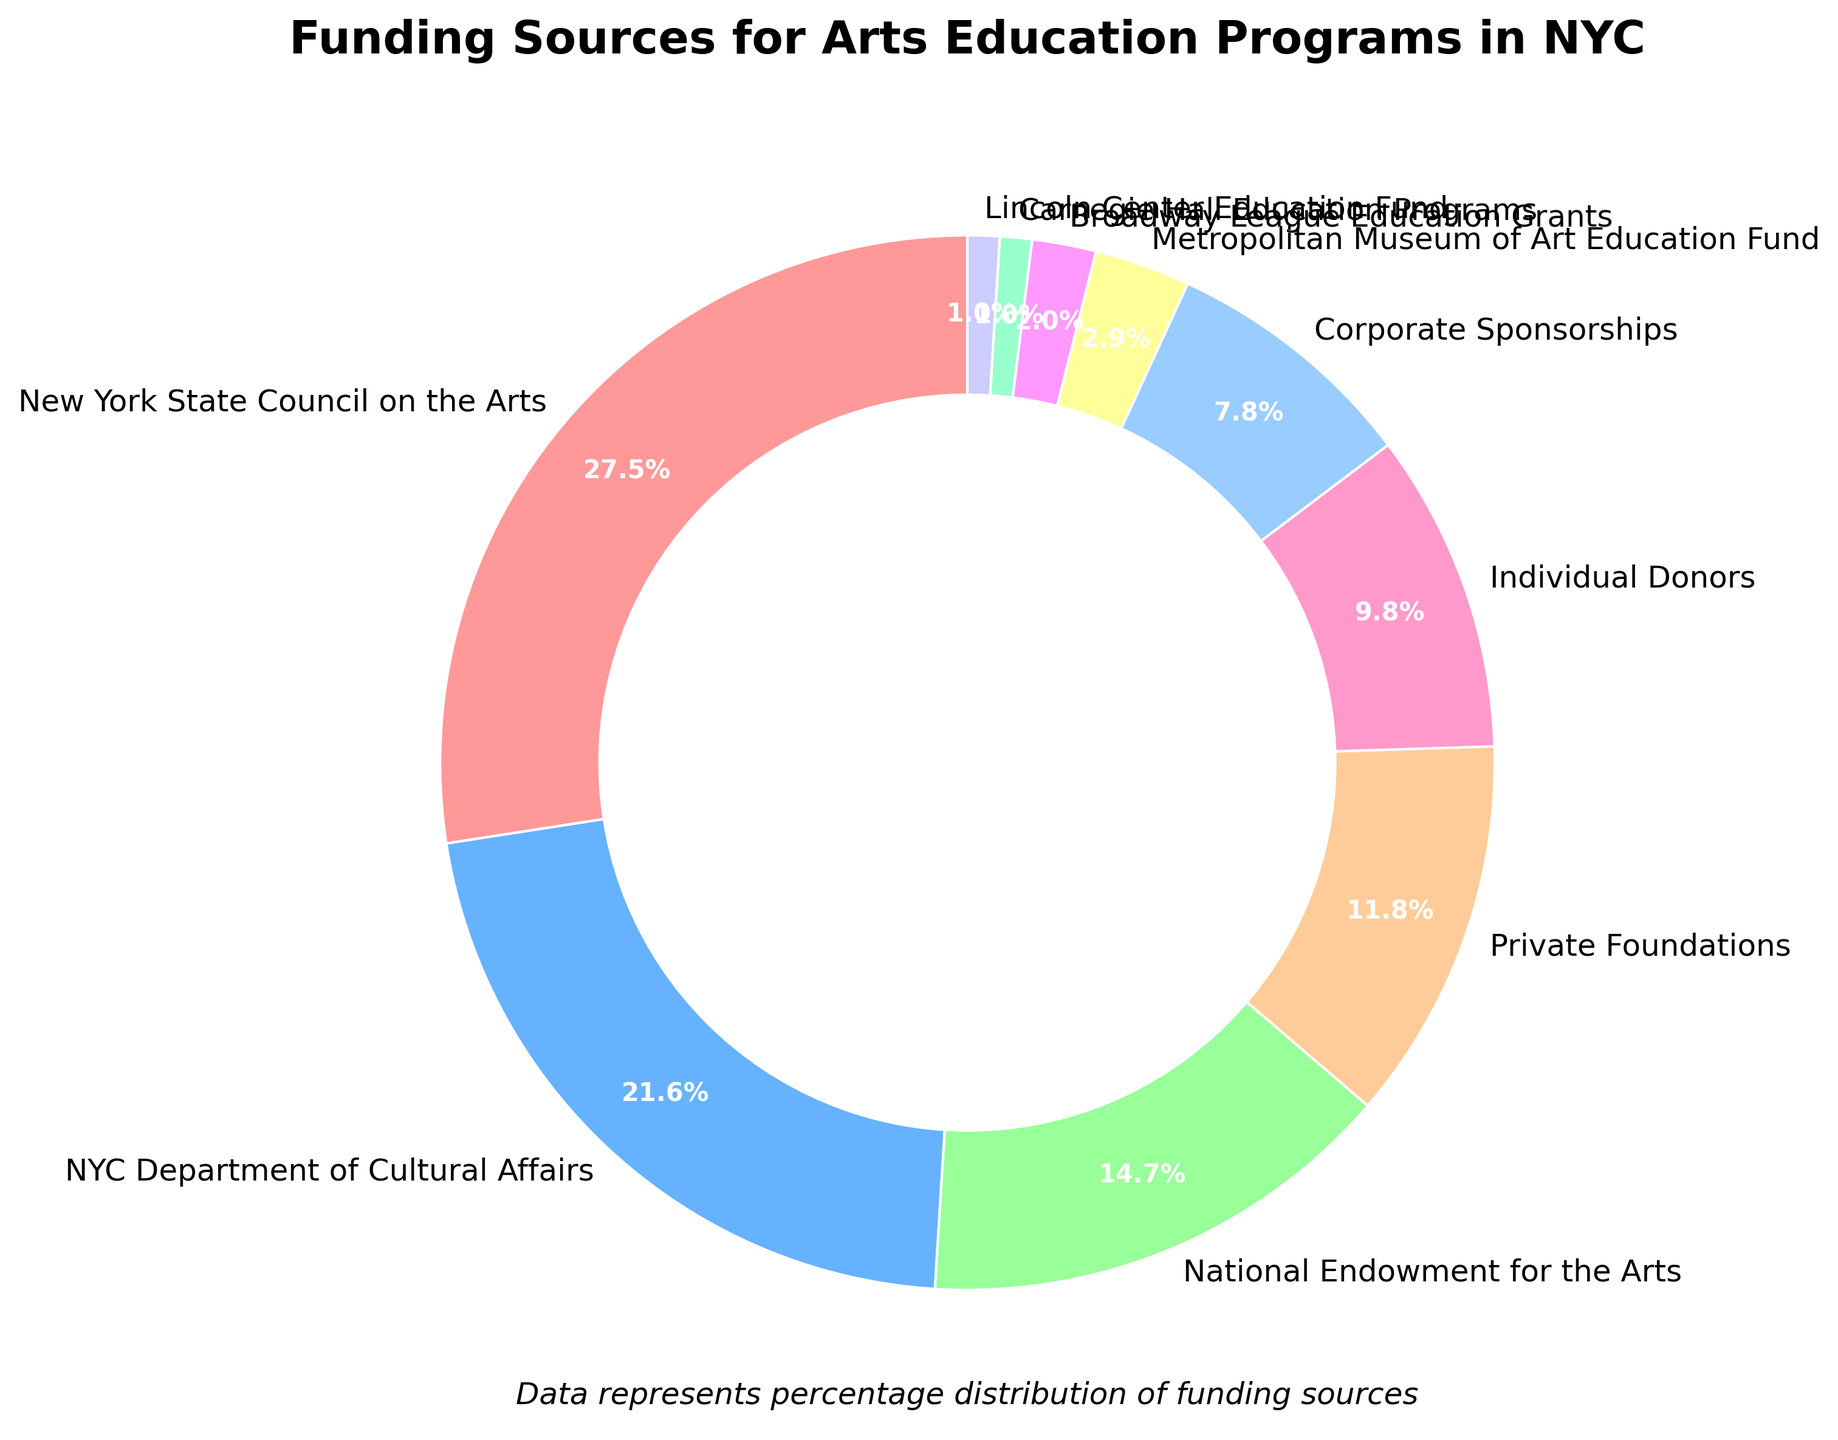What is the most significant funding source for arts education programs in NYC? To determine the most significant funding source, look for the segment on the pie chart with the largest percentage. The New York State Council on the Arts, at 28%, is the largest segment.
Answer: New York State Council on the Arts Which funding source contributes more, Private Foundations or Individual Donors? Compare the pie segments of Private Foundations (12%) and Individual Donors (10%). Since 12% is greater than 10%, Private Foundations contribute more.
Answer: Private Foundations What are the combined contributions of Corporate Sponsorships and Private Foundations? Find the percentages of Corporate Sponsorships (8%) and Private Foundations (12%) on the chart and add them up: 8% + 12% = 20%.
Answer: 20% Does the contribution from the NYC Department of Cultural Affairs exceed that from the National Endowment for the Arts? Compare the pie segments of the NYC Department of Cultural Affairs (22%) and the National Endowment for the Arts (15%). Since 22% is greater than 15%, it does exceed.
Answer: Yes Which two funding sources together are the smallest contributors? Look for the two smallest segments on the pie chart. Carnegie Hall Education Programs and Lincoln Center Education Fund each contribute 1%. Together, they total 1% + 1% = 2%.
Answer: Carnegie Hall Education Programs and Lincoln Center Education Fund By how much does the New York State Council on the Arts' contribution exceed that of Private Foundations? Subtract the percentage of Private Foundations (12%) from that of the New York State Council on the Arts (28%): 28% - 12% = 16%.
Answer: 16% What percentage of the total funding is contributed by sources other than the top three (New York State Council on the Arts, NYC Department of Cultural Affairs, and National Endowment for the Arts)? First, find the total percentage of the top three sources: 28% + 22% + 15% = 65%. Then, subtract this from 100% to get the remaining percentage: 100% - 65% = 35%.
Answer: 35% Which funding source is represented in blue on the pie chart? Colours can be inferred by looking at the legend or corresponding labels. The second-highest percentage (NYC Department of Cultural Affairs at 22%) is typically assigned a contrasting color like blue.
Answer: NYC Department of Cultural Affairs 